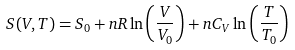<formula> <loc_0><loc_0><loc_500><loc_500>S ( V , T ) = S _ { 0 } + n R \ln \left ( { \frac { V } { V _ { 0 } } } \right ) + n C _ { V } \ln \left ( { \frac { T } { T _ { 0 } } } \right )</formula> 